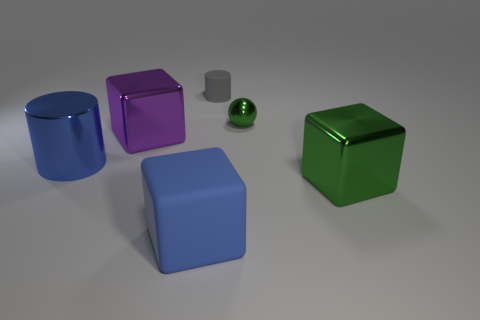What might be the function of these objects if they were to be used in a real-life setting? In a real-life setting, these could be children's toy blocks designed for educational purposes, aiding in the development of spatial awareness and motor skills. Their different colors and materials also add a sensory component to the playing experience. 